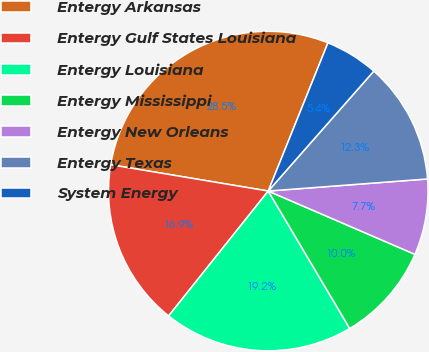<chart> <loc_0><loc_0><loc_500><loc_500><pie_chart><fcel>Entergy Arkansas<fcel>Entergy Gulf States Louisiana<fcel>Entergy Louisiana<fcel>Entergy Mississippi<fcel>Entergy New Orleans<fcel>Entergy Texas<fcel>System Energy<nl><fcel>28.46%<fcel>16.92%<fcel>19.23%<fcel>10.0%<fcel>7.69%<fcel>12.31%<fcel>5.39%<nl></chart> 